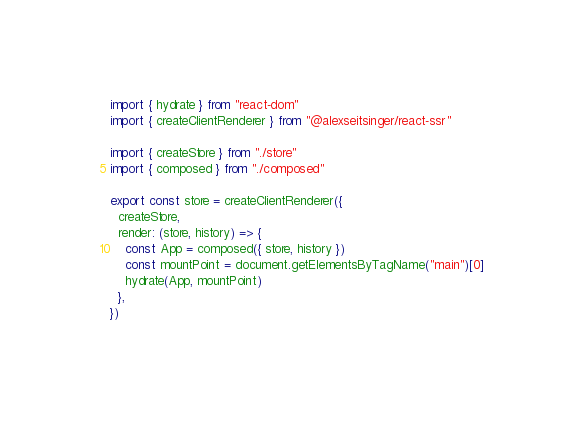<code> <loc_0><loc_0><loc_500><loc_500><_JavaScript_>import { hydrate } from "react-dom"
import { createClientRenderer } from "@alexseitsinger/react-ssr"

import { createStore } from "./store"
import { composed } from "./composed"

export const store = createClientRenderer({
  createStore,
  render: (store, history) => {
    const App = composed({ store, history })
    const mountPoint = document.getElementsByTagName("main")[0]
    hydrate(App, mountPoint)
  },
})
</code> 